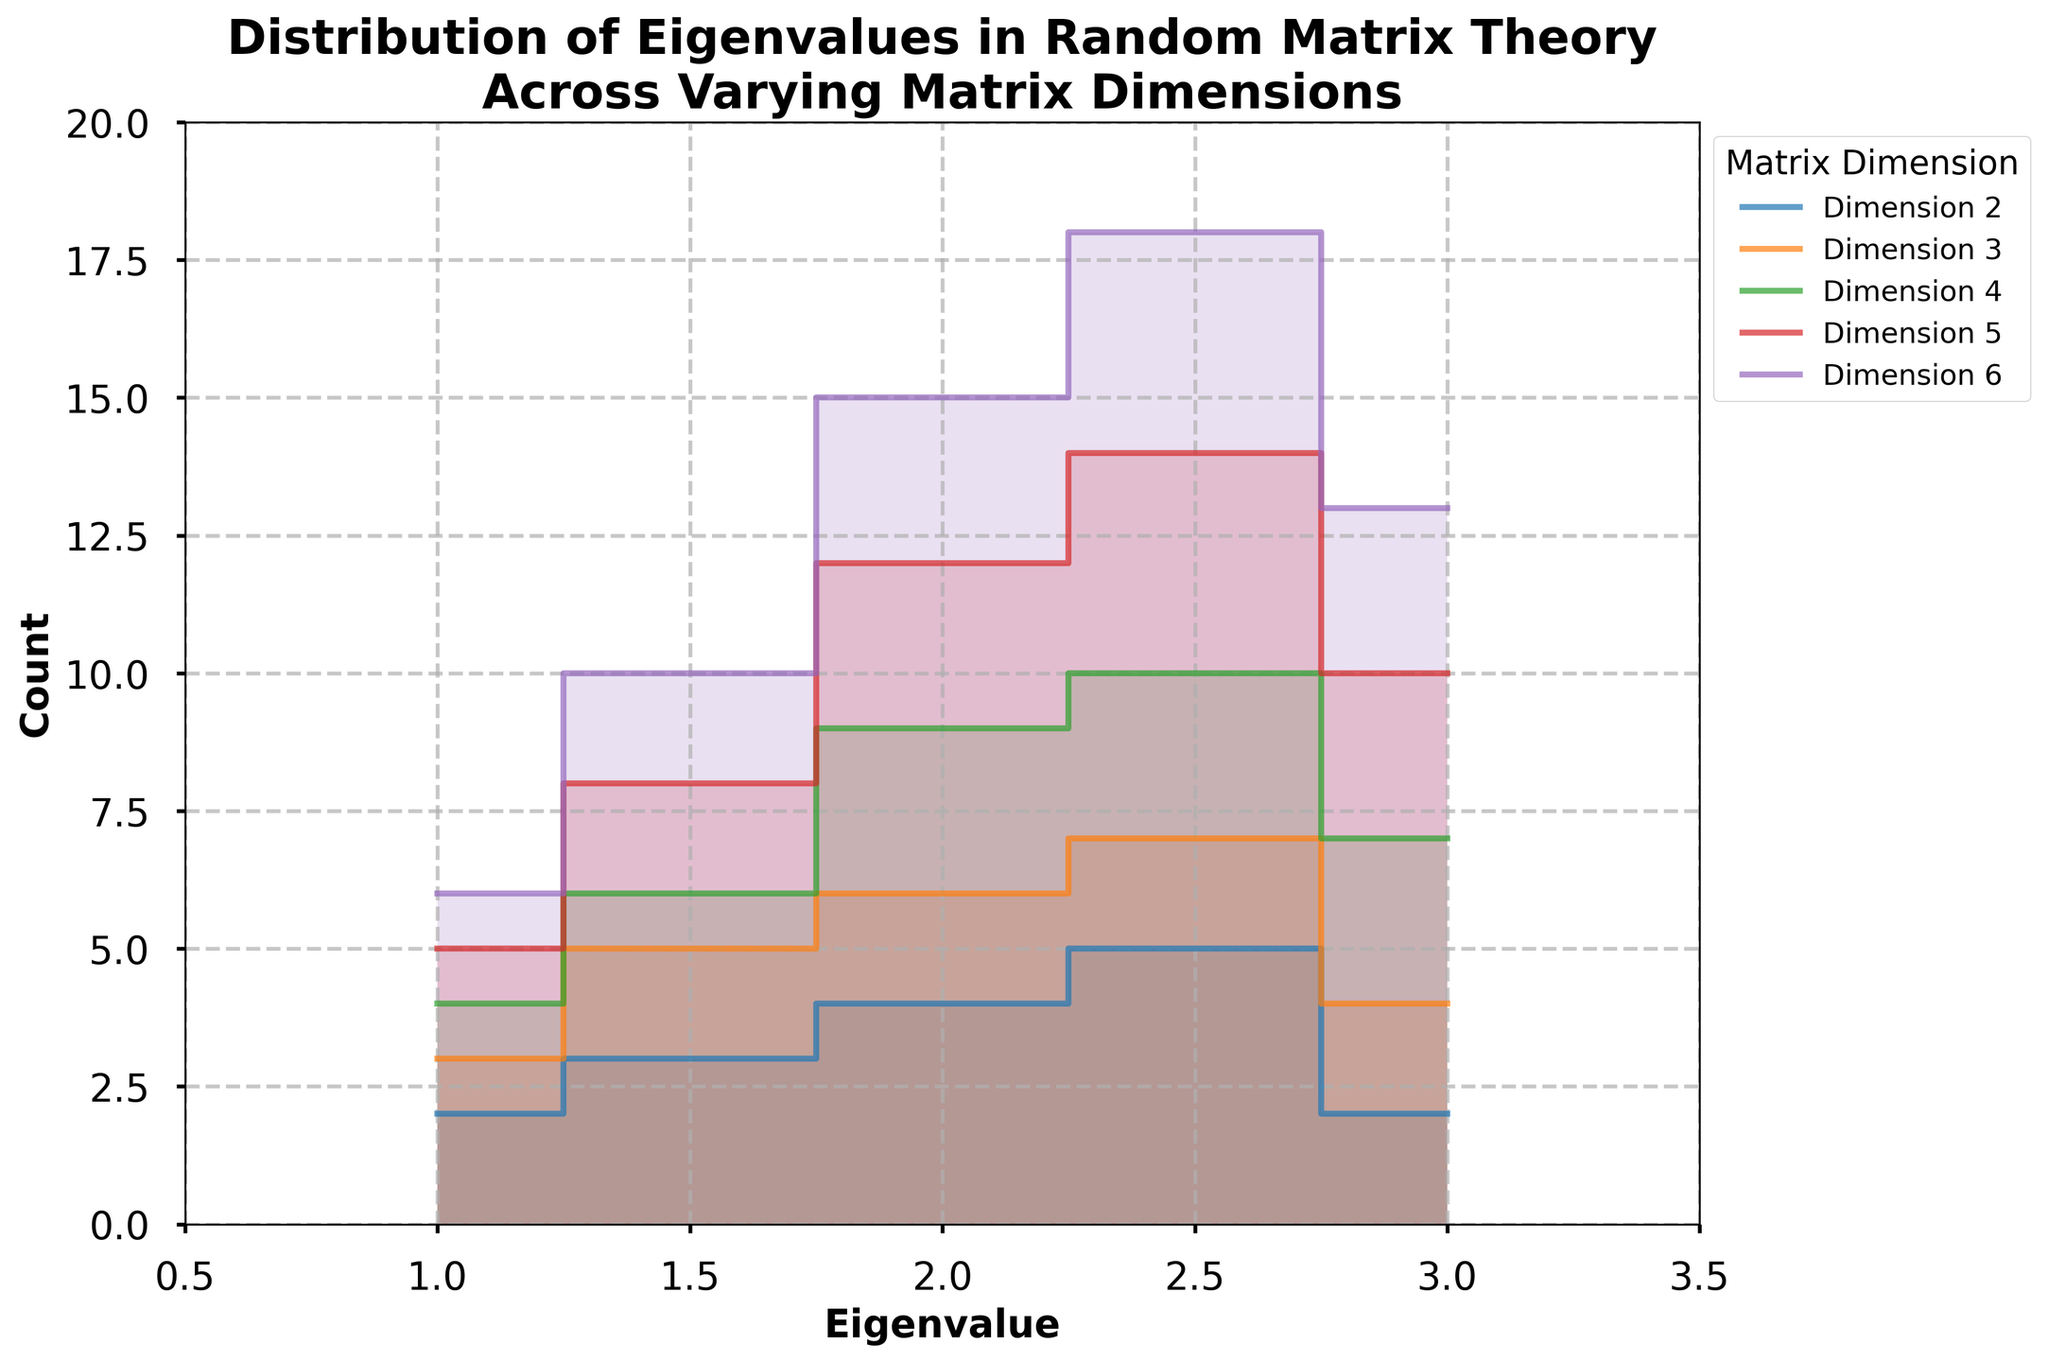What is the title of the chart? The title of the chart is displayed prominently at the top. It reads "Distribution of Eigenvalues in Random Matrix Theory Across Varying Matrix Dimensions".
Answer: Distribution of Eigenvalues in Random Matrix Theory Across Varying Matrix Dimensions How many matrix dimensions are represented in the chart? By examining the legend on the chart, we see that there are different lines and fills for each matrix dimension. The number of labels in the legend gives us the number of matrix dimensions.
Answer: 5 What is the value range for the eigenvalues along the x-axis? The x-axis is labeled "Eigenvalue" with tick marks and the range is visually marked from 0.5 to 3.5.
Answer: 0.5 to 3.5 Which matrix dimension has the highest count for eigenvalues at 2.5? To determine this, look for the highest point in the step chart aligned with the eigenvalue 2.5. The matrix dimension with the largest peak at this point in the chart is the one with the highest count.
Answer: Dimension 6 What is the relationship between the count of eigenvalues for dimensions 3 and 5 at eigenvalue 3.0? Locate the counts for eigenvalue 3.0 on the step chart for both dimensions 3 and 5. Dimension 5 has a higher count at 3.0 compared to dimension 3.
Answer: Dimension 5 has a higher count Which dimension shows the steepest increase in count between eigenvalues 2.0 and 2.5? Observe the slopes of the steps between eigenvalues 2.0 and 2.5. The dimension with the steepest slope will have the sharpest increase in count visually.
Answer: Dimension 6 What is the total count of eigenvalues for dimension 4 across all eigenvalues? Sum the counts of eigenvalues for dimension 4 from the step chart. The counts are 4, 6, 9, 10, 7.
Answer: 36 How does the count for eigenvalue 1.5 compare between dimensions 2 and 4? Compare the values at eigenvalue 1.5 on the step chart for dimensions 2 and 4. Dimension 4 has a higher count at 1.5 than dimension 2.
Answer: Dimension 4 has a higher count Which matrix dimension has the most counts for the eigenvalue range between 1.0 and 1.5? To determine this, compare the counts within the range between 1.0 and 1.5 for all dimensions. Dimension 6 has the highest counts in this range.
Answer: Dimension 6 How do the counts for dimension 2 at eigenvalue 2.5 compare to those at eigenvalue 3.0? By comparing the step increases at eigenvalues 2.5 and 3.0 for dimension 2, we find the values correspond to the counts. The count at 2.5 is higher than the count at 3.0.
Answer: Higher at 2.5 